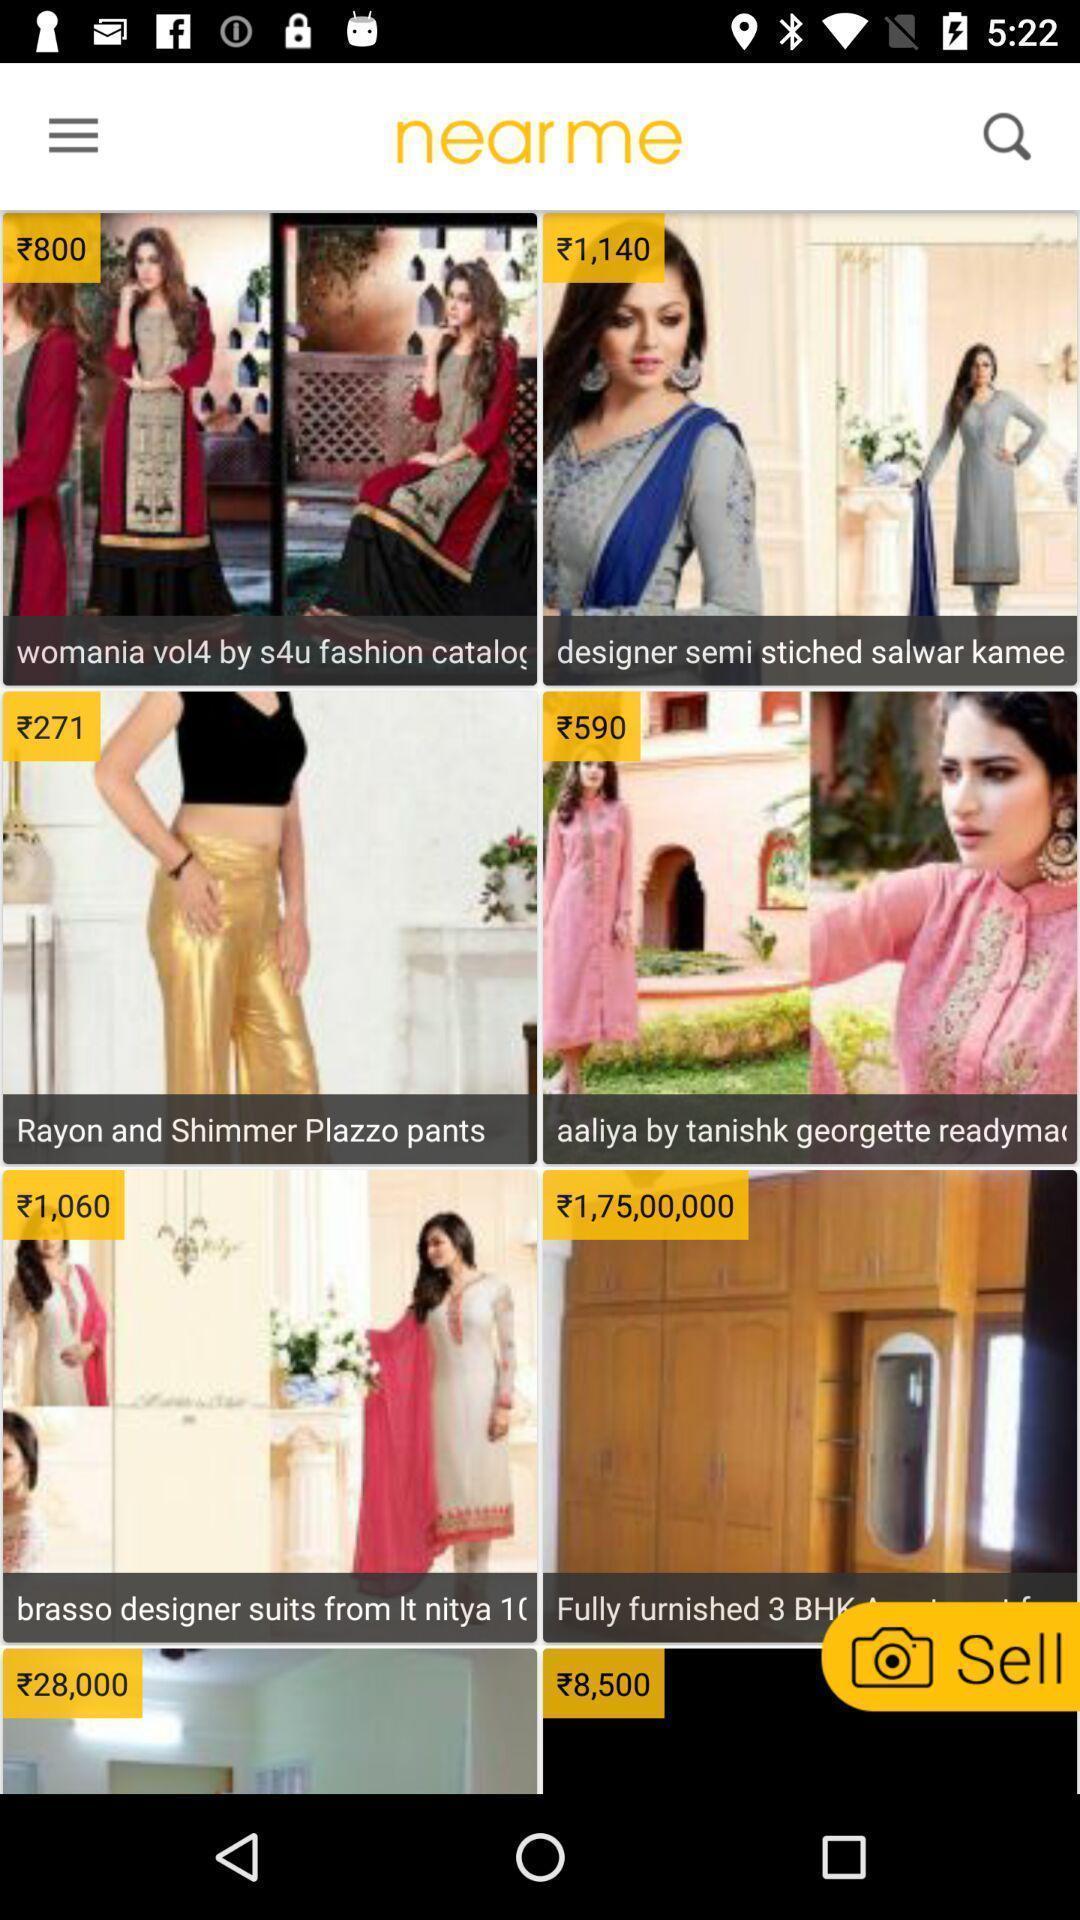Explain what's happening in this screen capture. Screen displaying multiple product images with price. 